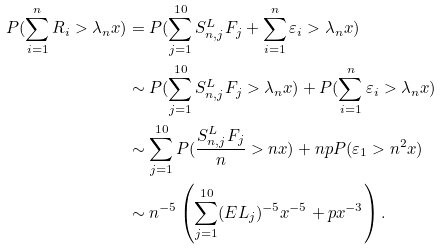Convert formula to latex. <formula><loc_0><loc_0><loc_500><loc_500>P ( \sum _ { i = 1 } ^ { n } R _ { i } > \lambda _ { n } x ) & = P ( \sum _ { j = 1 } ^ { 1 0 } S _ { n , j } ^ { L } F _ { j } + \sum _ { i = 1 } ^ { n } \varepsilon _ { i } > \lambda _ { n } x ) \\ & \sim P ( \sum _ { j = 1 } ^ { 1 0 } S _ { n , j } ^ { L } F _ { j } > \lambda _ { n } x ) + P ( \sum _ { i = 1 } ^ { n } \varepsilon _ { i } > \lambda _ { n } x ) \\ & \sim \sum _ { j = 1 } ^ { 1 0 } P ( \frac { S _ { n , j } ^ { L } F _ { j } } { n } > n x ) + n p P ( \varepsilon _ { 1 } > n ^ { 2 } x ) \\ & \sim n ^ { - 5 } \left ( \sum _ { j = 1 } ^ { 1 0 } ( E L _ { j } ) ^ { - 5 } x ^ { - 5 } + p x ^ { - 3 } \right ) .</formula> 